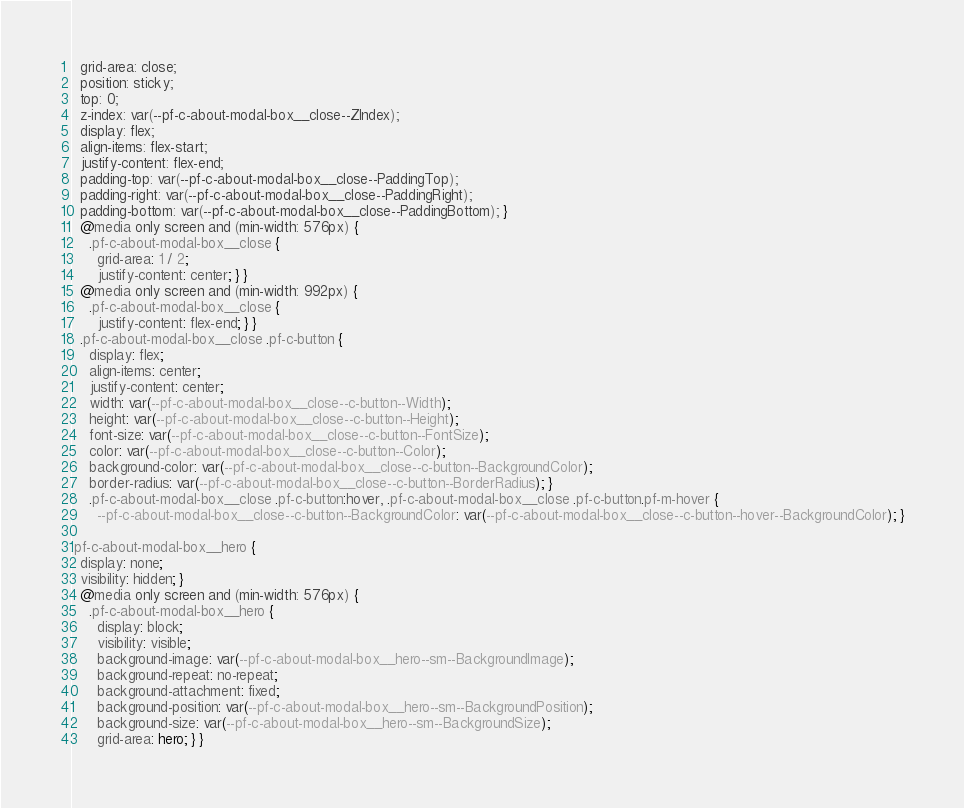Convert code to text. <code><loc_0><loc_0><loc_500><loc_500><_CSS_>  grid-area: close;
  position: sticky;
  top: 0;
  z-index: var(--pf-c-about-modal-box__close--ZIndex);
  display: flex;
  align-items: flex-start;
  justify-content: flex-end;
  padding-top: var(--pf-c-about-modal-box__close--PaddingTop);
  padding-right: var(--pf-c-about-modal-box__close--PaddingRight);
  padding-bottom: var(--pf-c-about-modal-box__close--PaddingBottom); }
  @media only screen and (min-width: 576px) {
    .pf-c-about-modal-box__close {
      grid-area: 1 / 2;
      justify-content: center; } }
  @media only screen and (min-width: 992px) {
    .pf-c-about-modal-box__close {
      justify-content: flex-end; } }
  .pf-c-about-modal-box__close .pf-c-button {
    display: flex;
    align-items: center;
    justify-content: center;
    width: var(--pf-c-about-modal-box__close--c-button--Width);
    height: var(--pf-c-about-modal-box__close--c-button--Height);
    font-size: var(--pf-c-about-modal-box__close--c-button--FontSize);
    color: var(--pf-c-about-modal-box__close--c-button--Color);
    background-color: var(--pf-c-about-modal-box__close--c-button--BackgroundColor);
    border-radius: var(--pf-c-about-modal-box__close--c-button--BorderRadius); }
    .pf-c-about-modal-box__close .pf-c-button:hover, .pf-c-about-modal-box__close .pf-c-button.pf-m-hover {
      --pf-c-about-modal-box__close--c-button--BackgroundColor: var(--pf-c-about-modal-box__close--c-button--hover--BackgroundColor); }

.pf-c-about-modal-box__hero {
  display: none;
  visibility: hidden; }
  @media only screen and (min-width: 576px) {
    .pf-c-about-modal-box__hero {
      display: block;
      visibility: visible;
      background-image: var(--pf-c-about-modal-box__hero--sm--BackgroundImage);
      background-repeat: no-repeat;
      background-attachment: fixed;
      background-position: var(--pf-c-about-modal-box__hero--sm--BackgroundPosition);
      background-size: var(--pf-c-about-modal-box__hero--sm--BackgroundSize);
      grid-area: hero; } }
</code> 